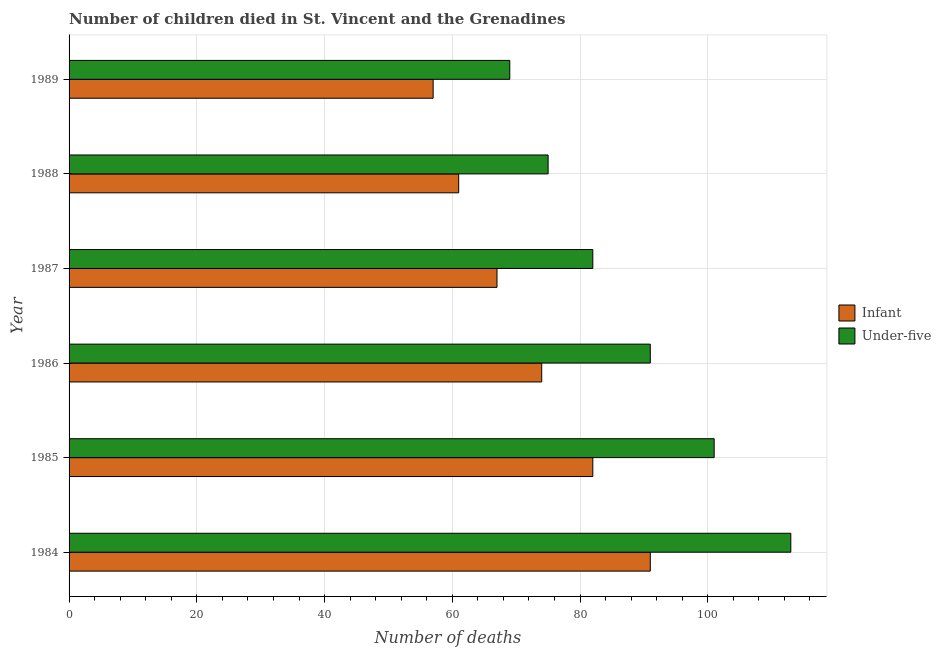How many different coloured bars are there?
Your response must be concise. 2. How many bars are there on the 6th tick from the top?
Give a very brief answer. 2. What is the label of the 3rd group of bars from the top?
Your answer should be compact. 1987. In how many cases, is the number of bars for a given year not equal to the number of legend labels?
Your response must be concise. 0. What is the number of under-five deaths in 1987?
Give a very brief answer. 82. Across all years, what is the maximum number of under-five deaths?
Your answer should be very brief. 113. Across all years, what is the minimum number of infant deaths?
Your response must be concise. 57. In which year was the number of under-five deaths maximum?
Provide a succinct answer. 1984. What is the total number of under-five deaths in the graph?
Ensure brevity in your answer.  531. What is the difference between the number of under-five deaths in 1984 and that in 1988?
Keep it short and to the point. 38. What is the difference between the number of under-five deaths in 1985 and the number of infant deaths in 1987?
Your response must be concise. 34. What is the average number of infant deaths per year?
Your answer should be very brief. 72. In the year 1986, what is the difference between the number of infant deaths and number of under-five deaths?
Your response must be concise. -17. What is the ratio of the number of under-five deaths in 1984 to that in 1988?
Your answer should be very brief. 1.51. Is the number of under-five deaths in 1985 less than that in 1986?
Provide a short and direct response. No. What is the difference between the highest and the lowest number of infant deaths?
Your response must be concise. 34. In how many years, is the number of infant deaths greater than the average number of infant deaths taken over all years?
Offer a terse response. 3. What does the 2nd bar from the top in 1988 represents?
Offer a very short reply. Infant. What does the 1st bar from the bottom in 1988 represents?
Provide a succinct answer. Infant. What is the difference between two consecutive major ticks on the X-axis?
Provide a succinct answer. 20. Does the graph contain grids?
Your response must be concise. Yes. Where does the legend appear in the graph?
Give a very brief answer. Center right. What is the title of the graph?
Your response must be concise. Number of children died in St. Vincent and the Grenadines. What is the label or title of the X-axis?
Your answer should be compact. Number of deaths. What is the Number of deaths in Infant in 1984?
Your answer should be compact. 91. What is the Number of deaths of Under-five in 1984?
Your answer should be compact. 113. What is the Number of deaths in Under-five in 1985?
Offer a very short reply. 101. What is the Number of deaths of Under-five in 1986?
Give a very brief answer. 91. What is the Number of deaths of Under-five in 1987?
Your answer should be very brief. 82. What is the Number of deaths of Infant in 1988?
Make the answer very short. 61. What is the Number of deaths of Infant in 1989?
Make the answer very short. 57. Across all years, what is the maximum Number of deaths of Infant?
Give a very brief answer. 91. Across all years, what is the maximum Number of deaths of Under-five?
Your answer should be compact. 113. Across all years, what is the minimum Number of deaths in Under-five?
Offer a very short reply. 69. What is the total Number of deaths of Infant in the graph?
Your response must be concise. 432. What is the total Number of deaths in Under-five in the graph?
Give a very brief answer. 531. What is the difference between the Number of deaths of Under-five in 1984 and that in 1985?
Keep it short and to the point. 12. What is the difference between the Number of deaths of Infant in 1984 and that in 1986?
Give a very brief answer. 17. What is the difference between the Number of deaths of Under-five in 1984 and that in 1986?
Keep it short and to the point. 22. What is the difference between the Number of deaths of Infant in 1984 and that in 1987?
Make the answer very short. 24. What is the difference between the Number of deaths in Under-five in 1984 and that in 1987?
Make the answer very short. 31. What is the difference between the Number of deaths of Infant in 1985 and that in 1986?
Your answer should be very brief. 8. What is the difference between the Number of deaths of Under-five in 1985 and that in 1986?
Provide a succinct answer. 10. What is the difference between the Number of deaths in Infant in 1985 and that in 1987?
Offer a terse response. 15. What is the difference between the Number of deaths of Infant in 1985 and that in 1989?
Give a very brief answer. 25. What is the difference between the Number of deaths of Under-five in 1986 and that in 1987?
Give a very brief answer. 9. What is the difference between the Number of deaths of Infant in 1986 and that in 1988?
Your answer should be compact. 13. What is the difference between the Number of deaths in Infant in 1987 and that in 1988?
Offer a terse response. 6. What is the difference between the Number of deaths in Infant in 1987 and that in 1989?
Ensure brevity in your answer.  10. What is the difference between the Number of deaths of Under-five in 1987 and that in 1989?
Provide a succinct answer. 13. What is the difference between the Number of deaths in Infant in 1984 and the Number of deaths in Under-five in 1988?
Give a very brief answer. 16. What is the difference between the Number of deaths of Infant in 1984 and the Number of deaths of Under-five in 1989?
Ensure brevity in your answer.  22. What is the difference between the Number of deaths in Infant in 1985 and the Number of deaths in Under-five in 1986?
Give a very brief answer. -9. What is the difference between the Number of deaths of Infant in 1986 and the Number of deaths of Under-five in 1988?
Provide a short and direct response. -1. What is the difference between the Number of deaths in Infant in 1986 and the Number of deaths in Under-five in 1989?
Give a very brief answer. 5. What is the difference between the Number of deaths in Infant in 1987 and the Number of deaths in Under-five in 1989?
Your answer should be very brief. -2. What is the average Number of deaths of Under-five per year?
Offer a very short reply. 88.5. In the year 1984, what is the difference between the Number of deaths in Infant and Number of deaths in Under-five?
Keep it short and to the point. -22. In the year 1986, what is the difference between the Number of deaths in Infant and Number of deaths in Under-five?
Provide a succinct answer. -17. In the year 1987, what is the difference between the Number of deaths of Infant and Number of deaths of Under-five?
Make the answer very short. -15. In the year 1988, what is the difference between the Number of deaths in Infant and Number of deaths in Under-five?
Keep it short and to the point. -14. What is the ratio of the Number of deaths of Infant in 1984 to that in 1985?
Provide a short and direct response. 1.11. What is the ratio of the Number of deaths of Under-five in 1984 to that in 1985?
Offer a terse response. 1.12. What is the ratio of the Number of deaths in Infant in 1984 to that in 1986?
Your answer should be compact. 1.23. What is the ratio of the Number of deaths in Under-five in 1984 to that in 1986?
Your answer should be very brief. 1.24. What is the ratio of the Number of deaths of Infant in 1984 to that in 1987?
Make the answer very short. 1.36. What is the ratio of the Number of deaths of Under-five in 1984 to that in 1987?
Provide a short and direct response. 1.38. What is the ratio of the Number of deaths of Infant in 1984 to that in 1988?
Give a very brief answer. 1.49. What is the ratio of the Number of deaths of Under-five in 1984 to that in 1988?
Offer a very short reply. 1.51. What is the ratio of the Number of deaths in Infant in 1984 to that in 1989?
Your answer should be very brief. 1.6. What is the ratio of the Number of deaths of Under-five in 1984 to that in 1989?
Make the answer very short. 1.64. What is the ratio of the Number of deaths of Infant in 1985 to that in 1986?
Provide a short and direct response. 1.11. What is the ratio of the Number of deaths of Under-five in 1985 to that in 1986?
Provide a short and direct response. 1.11. What is the ratio of the Number of deaths of Infant in 1985 to that in 1987?
Give a very brief answer. 1.22. What is the ratio of the Number of deaths of Under-five in 1985 to that in 1987?
Offer a terse response. 1.23. What is the ratio of the Number of deaths in Infant in 1985 to that in 1988?
Provide a succinct answer. 1.34. What is the ratio of the Number of deaths in Under-five in 1985 to that in 1988?
Keep it short and to the point. 1.35. What is the ratio of the Number of deaths of Infant in 1985 to that in 1989?
Keep it short and to the point. 1.44. What is the ratio of the Number of deaths in Under-five in 1985 to that in 1989?
Give a very brief answer. 1.46. What is the ratio of the Number of deaths in Infant in 1986 to that in 1987?
Give a very brief answer. 1.1. What is the ratio of the Number of deaths in Under-five in 1986 to that in 1987?
Your response must be concise. 1.11. What is the ratio of the Number of deaths in Infant in 1986 to that in 1988?
Keep it short and to the point. 1.21. What is the ratio of the Number of deaths in Under-five in 1986 to that in 1988?
Provide a succinct answer. 1.21. What is the ratio of the Number of deaths in Infant in 1986 to that in 1989?
Provide a succinct answer. 1.3. What is the ratio of the Number of deaths in Under-five in 1986 to that in 1989?
Give a very brief answer. 1.32. What is the ratio of the Number of deaths of Infant in 1987 to that in 1988?
Offer a very short reply. 1.1. What is the ratio of the Number of deaths in Under-five in 1987 to that in 1988?
Ensure brevity in your answer.  1.09. What is the ratio of the Number of deaths of Infant in 1987 to that in 1989?
Make the answer very short. 1.18. What is the ratio of the Number of deaths of Under-five in 1987 to that in 1989?
Provide a succinct answer. 1.19. What is the ratio of the Number of deaths in Infant in 1988 to that in 1989?
Offer a very short reply. 1.07. What is the ratio of the Number of deaths in Under-five in 1988 to that in 1989?
Provide a short and direct response. 1.09. What is the difference between the highest and the second highest Number of deaths in Infant?
Provide a succinct answer. 9. What is the difference between the highest and the lowest Number of deaths in Under-five?
Provide a short and direct response. 44. 